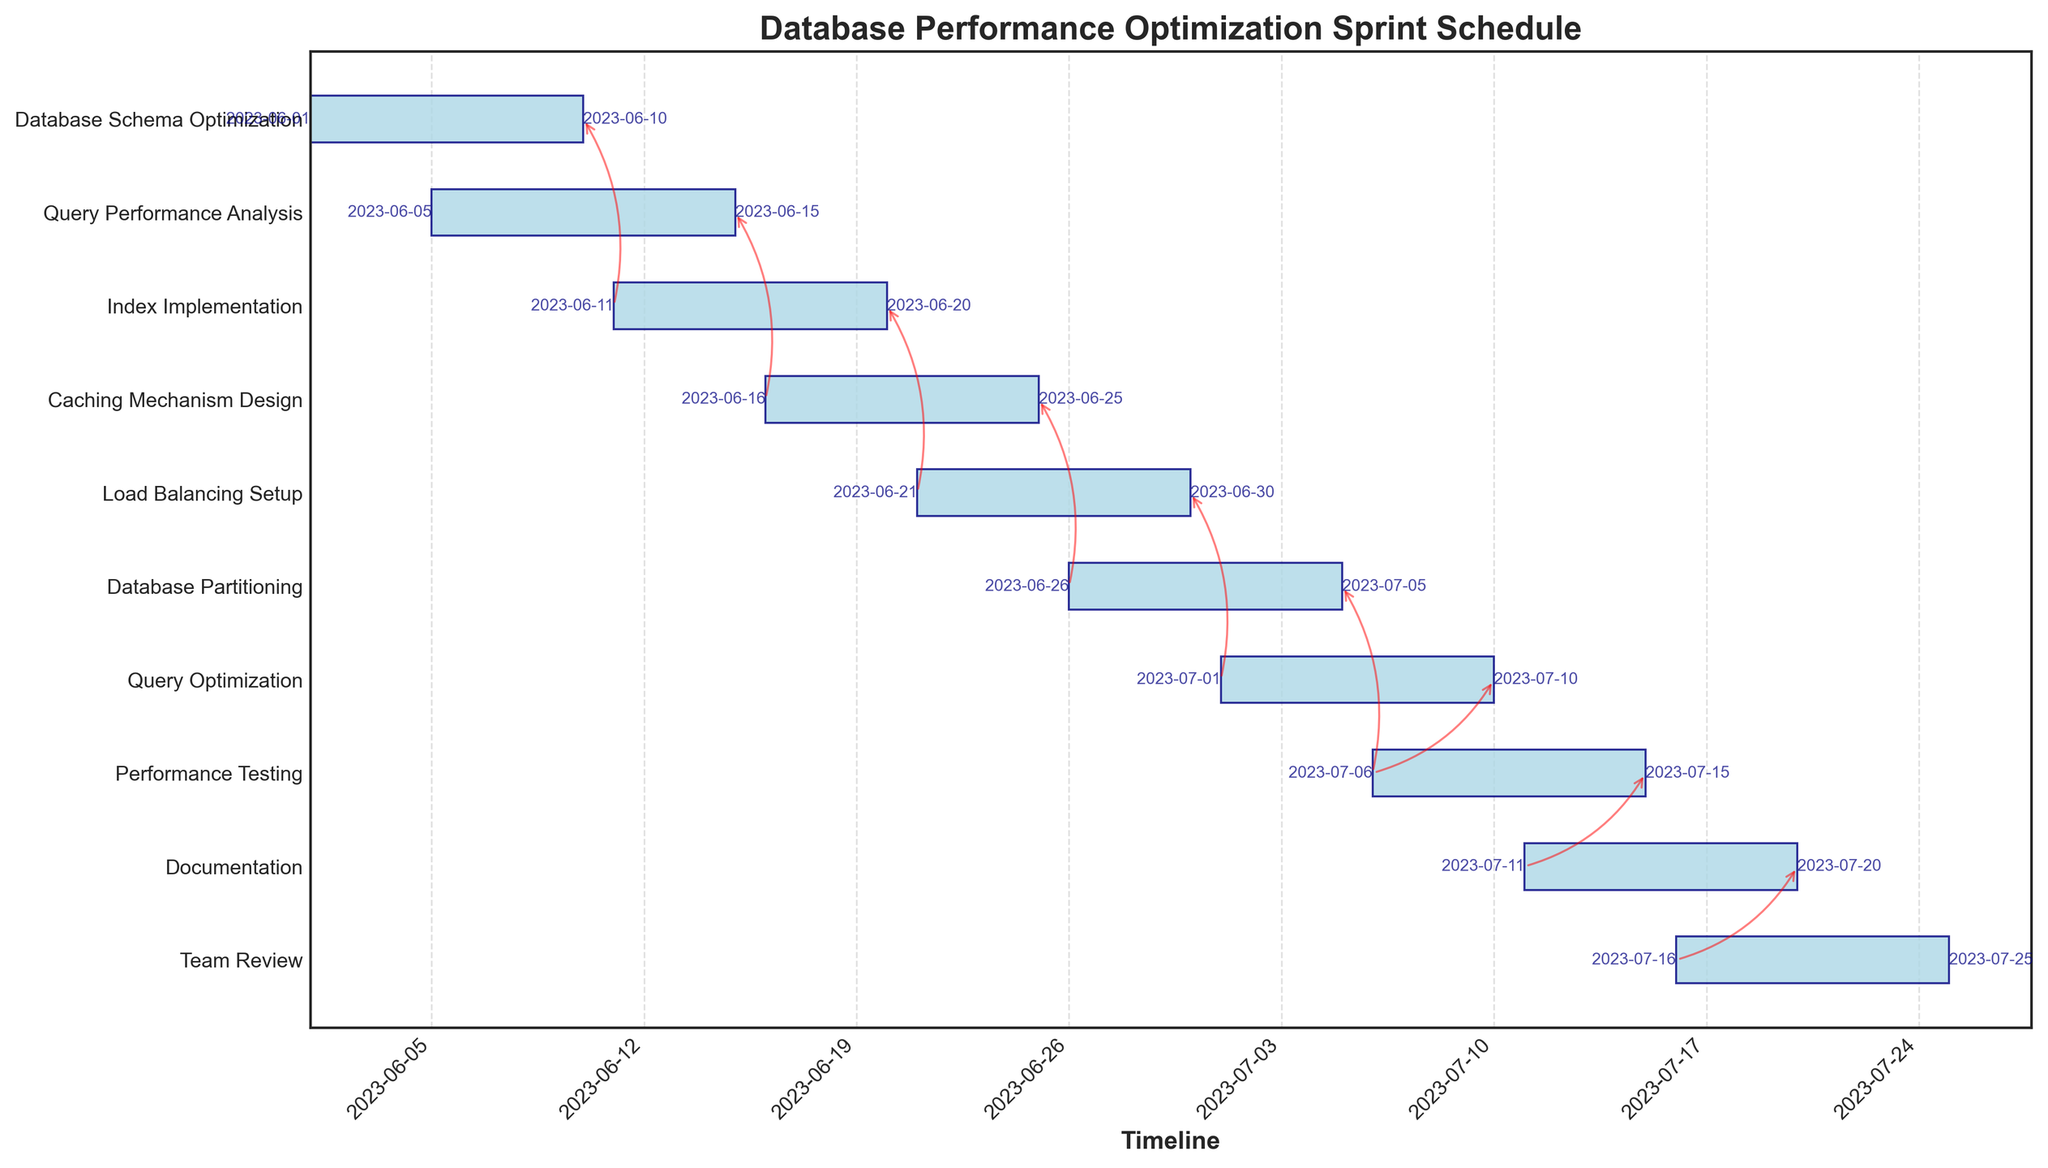Which task starts first in the sprint schedule? By looking at the Gantt Chart, the task that appears furthest to the left along the timeline is the task that starts first.
Answer: Database Schema Optimization Which task has the longest duration? The task with the longest horizontal bar in the Gantt Chart represents the task with the longest duration.
Answer: Query Performance Analysis What is the title of the chart? The title is typically located at the top of the chart and provides a brief description of its contents.
Answer: Database Performance Optimization Sprint Schedule How many tasks are there in total on the Gantt Chart? Count the number of labels on the y-axis, as each label corresponds to a task.
Answer: 10 Which task directly depends on Caching Mechanism Design? Identify the arrows indicating dependencies that originate from the end of Caching Mechanism Design and point to another task's start.
Answer: Database Partitioning What is the duration of the Load Balancing Setup task? The duration is the length of the bar for Load Balancing Setup, which corresponds to the number of days between its start and end dates.
Answer: 9 days Which tasks have multiple dependencies? Look for tasks that have multiple arrows pointing to them from different starting points.
Answer: Performance Testing Across the entire sprint schedule, which two tasks overlap completely in time? Find any two bars that start and end exactly at the same point along the timeline.
Answer: None How many dependencies does Database Partitioning have? Count the number of arrows that point to the bar representing Database Partitioning.
Answer: 1 Which task finishes at the latest date in the sprint schedule? Locate the task that ends furthest to the right on the timeline.
Answer: Team Review 